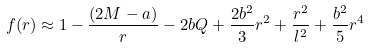<formula> <loc_0><loc_0><loc_500><loc_500>f ( r ) \approx 1 - \frac { ( 2 M - a ) } { r } - 2 b Q + \frac { 2 b ^ { 2 } } { 3 } r ^ { 2 } + \frac { r ^ { 2 } } { l ^ { 2 } } + \frac { b ^ { 2 } } { 5 } r ^ { 4 }</formula> 